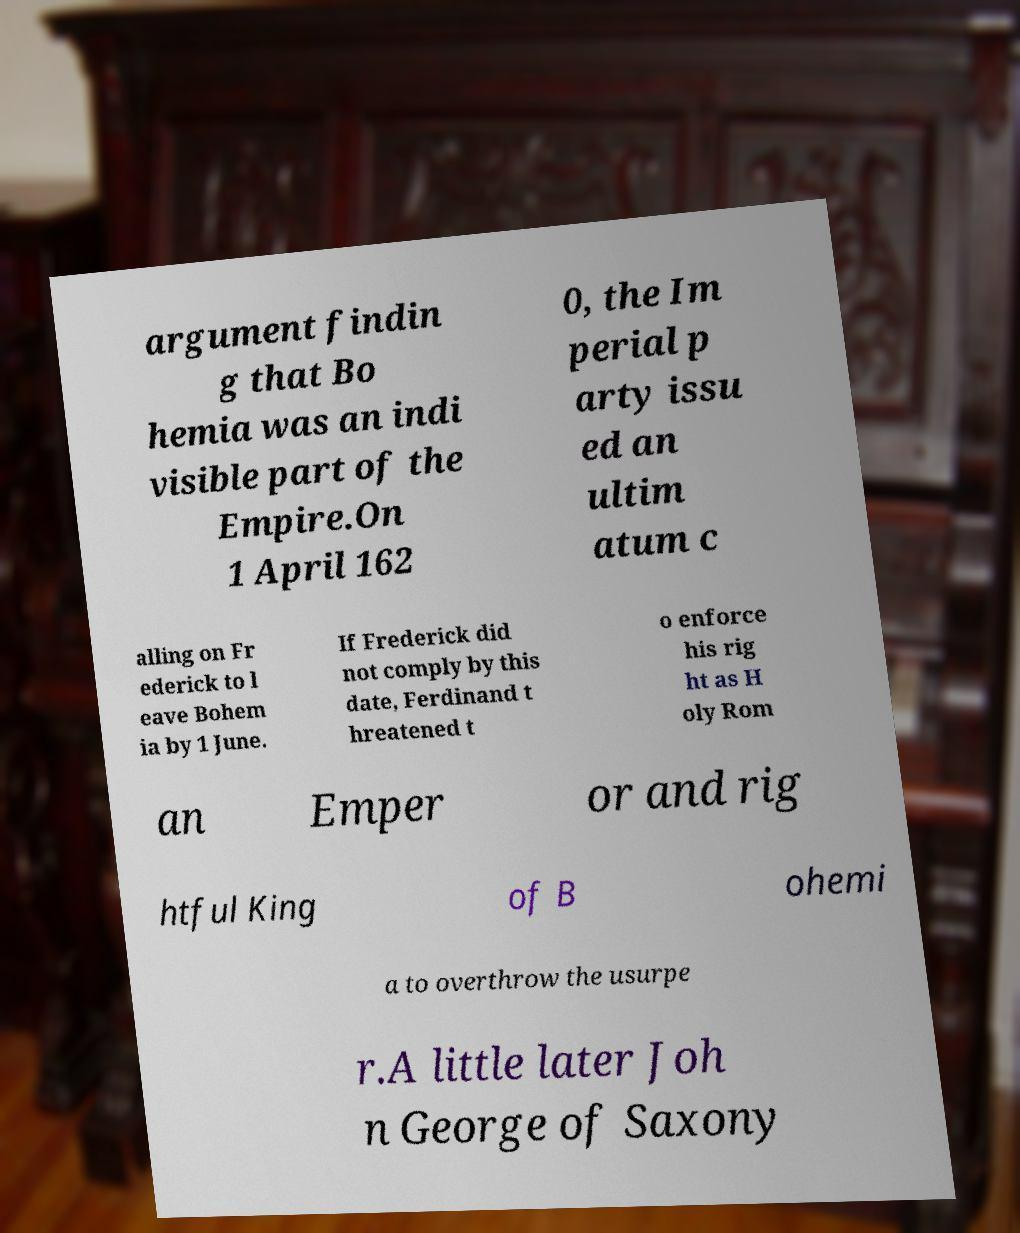Could you assist in decoding the text presented in this image and type it out clearly? argument findin g that Bo hemia was an indi visible part of the Empire.On 1 April 162 0, the Im perial p arty issu ed an ultim atum c alling on Fr ederick to l eave Bohem ia by 1 June. If Frederick did not comply by this date, Ferdinand t hreatened t o enforce his rig ht as H oly Rom an Emper or and rig htful King of B ohemi a to overthrow the usurpe r.A little later Joh n George of Saxony 